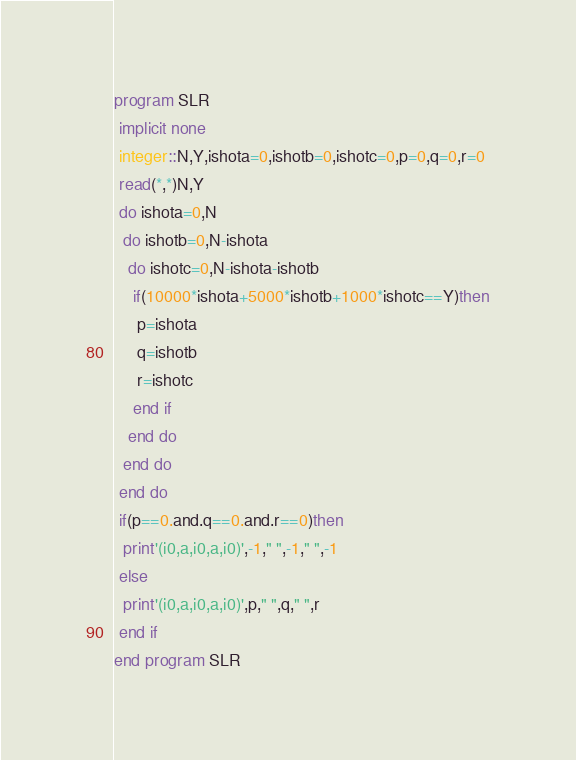<code> <loc_0><loc_0><loc_500><loc_500><_FORTRAN_>program SLR
 implicit none
 integer::N,Y,ishota=0,ishotb=0,ishotc=0,p=0,q=0,r=0
 read(*,*)N,Y
 do ishota=0,N
  do ishotb=0,N-ishota
   do ishotc=0,N-ishota-ishotb
    if(10000*ishota+5000*ishotb+1000*ishotc==Y)then
     p=ishota
     q=ishotb
     r=ishotc
    end if
   end do
  end do
 end do
 if(p==0.and.q==0.and.r==0)then
  print'(i0,a,i0,a,i0)',-1," ",-1," ",-1
 else
  print'(i0,a,i0,a,i0)',p," ",q," ",r
 end if
end program SLR</code> 